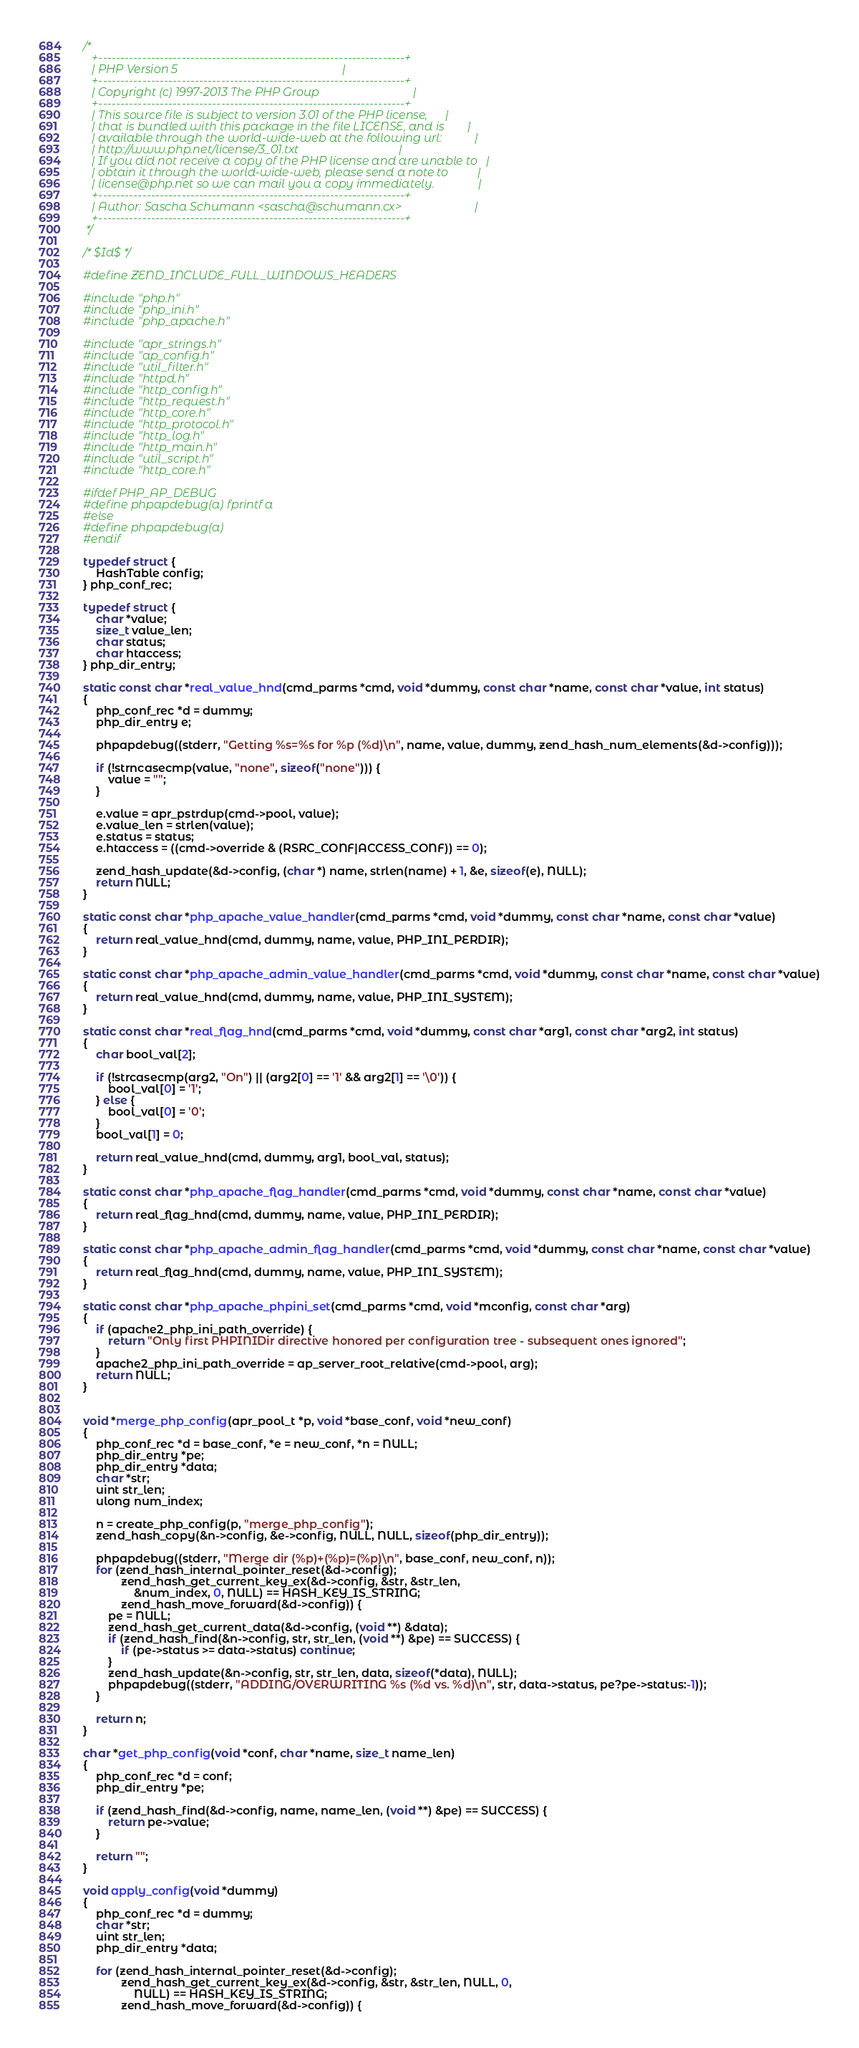Convert code to text. <code><loc_0><loc_0><loc_500><loc_500><_C_>/*
   +----------------------------------------------------------------------+
   | PHP Version 5                                                        |
   +----------------------------------------------------------------------+
   | Copyright (c) 1997-2013 The PHP Group                                |
   +----------------------------------------------------------------------+
   | This source file is subject to version 3.01 of the PHP license,      |
   | that is bundled with this package in the file LICENSE, and is        |
   | available through the world-wide-web at the following url:           |
   | http://www.php.net/license/3_01.txt                                  |
   | If you did not receive a copy of the PHP license and are unable to   |
   | obtain it through the world-wide-web, please send a note to          |
   | license@php.net so we can mail you a copy immediately.               |
   +----------------------------------------------------------------------+
   | Author: Sascha Schumann <sascha@schumann.cx>                         |
   +----------------------------------------------------------------------+
 */

/* $Id$ */

#define ZEND_INCLUDE_FULL_WINDOWS_HEADERS

#include "php.h"
#include "php_ini.h"
#include "php_apache.h"

#include "apr_strings.h"
#include "ap_config.h"
#include "util_filter.h"
#include "httpd.h"
#include "http_config.h"
#include "http_request.h"
#include "http_core.h"
#include "http_protocol.h"
#include "http_log.h"
#include "http_main.h"
#include "util_script.h"
#include "http_core.h"

#ifdef PHP_AP_DEBUG
#define phpapdebug(a) fprintf a
#else
#define phpapdebug(a)
#endif

typedef struct {
	HashTable config;
} php_conf_rec;

typedef struct {
	char *value;
	size_t value_len;
	char status;
	char htaccess;
} php_dir_entry;

static const char *real_value_hnd(cmd_parms *cmd, void *dummy, const char *name, const char *value, int status)
{
	php_conf_rec *d = dummy;
	php_dir_entry e;

	phpapdebug((stderr, "Getting %s=%s for %p (%d)\n", name, value, dummy, zend_hash_num_elements(&d->config)));
	
	if (!strncasecmp(value, "none", sizeof("none"))) {
		value = "";
	}
	
	e.value = apr_pstrdup(cmd->pool, value);
	e.value_len = strlen(value);
	e.status = status;
	e.htaccess = ((cmd->override & (RSRC_CONF|ACCESS_CONF)) == 0);

	zend_hash_update(&d->config, (char *) name, strlen(name) + 1, &e, sizeof(e), NULL);
	return NULL;
}

static const char *php_apache_value_handler(cmd_parms *cmd, void *dummy, const char *name, const char *value)
{
	return real_value_hnd(cmd, dummy, name, value, PHP_INI_PERDIR);
}

static const char *php_apache_admin_value_handler(cmd_parms *cmd, void *dummy, const char *name, const char *value)
{
	return real_value_hnd(cmd, dummy, name, value, PHP_INI_SYSTEM);
}

static const char *real_flag_hnd(cmd_parms *cmd, void *dummy, const char *arg1, const char *arg2, int status)
{
	char bool_val[2];

	if (!strcasecmp(arg2, "On") || (arg2[0] == '1' && arg2[1] == '\0')) {
		bool_val[0] = '1';
	} else {
		bool_val[0] = '0';
	}
	bool_val[1] = 0;

	return real_value_hnd(cmd, dummy, arg1, bool_val, status);
}

static const char *php_apache_flag_handler(cmd_parms *cmd, void *dummy, const char *name, const char *value)
{
	return real_flag_hnd(cmd, dummy, name, value, PHP_INI_PERDIR);
}

static const char *php_apache_admin_flag_handler(cmd_parms *cmd, void *dummy, const char *name, const char *value)
{
	return real_flag_hnd(cmd, dummy, name, value, PHP_INI_SYSTEM);
}

static const char *php_apache_phpini_set(cmd_parms *cmd, void *mconfig, const char *arg)
{
	if (apache2_php_ini_path_override) {
		return "Only first PHPINIDir directive honored per configuration tree - subsequent ones ignored";
	}
	apache2_php_ini_path_override = ap_server_root_relative(cmd->pool, arg);
	return NULL;
}


void *merge_php_config(apr_pool_t *p, void *base_conf, void *new_conf)
{
	php_conf_rec *d = base_conf, *e = new_conf, *n = NULL;
	php_dir_entry *pe;
	php_dir_entry *data;
	char *str;
	uint str_len;
	ulong num_index;

	n = create_php_config(p, "merge_php_config");
	zend_hash_copy(&n->config, &e->config, NULL, NULL, sizeof(php_dir_entry));

	phpapdebug((stderr, "Merge dir (%p)+(%p)=(%p)\n", base_conf, new_conf, n));
	for (zend_hash_internal_pointer_reset(&d->config);
			zend_hash_get_current_key_ex(&d->config, &str, &str_len, 
				&num_index, 0, NULL) == HASH_KEY_IS_STRING;
			zend_hash_move_forward(&d->config)) {
		pe = NULL;
		zend_hash_get_current_data(&d->config, (void **) &data);
		if (zend_hash_find(&n->config, str, str_len, (void **) &pe) == SUCCESS) {
			if (pe->status >= data->status) continue;
		}
		zend_hash_update(&n->config, str, str_len, data, sizeof(*data), NULL);
		phpapdebug((stderr, "ADDING/OVERWRITING %s (%d vs. %d)\n", str, data->status, pe?pe->status:-1));
	}

	return n;
}

char *get_php_config(void *conf, char *name, size_t name_len)
{
	php_conf_rec *d = conf;
	php_dir_entry *pe;
	
	if (zend_hash_find(&d->config, name, name_len, (void **) &pe) == SUCCESS) {
		return pe->value;
	}

	return "";
}

void apply_config(void *dummy)
{
	php_conf_rec *d = dummy;
	char *str;
	uint str_len;
	php_dir_entry *data;
	
	for (zend_hash_internal_pointer_reset(&d->config);
			zend_hash_get_current_key_ex(&d->config, &str, &str_len, NULL, 0, 
				NULL) == HASH_KEY_IS_STRING;
			zend_hash_move_forward(&d->config)) {</code> 